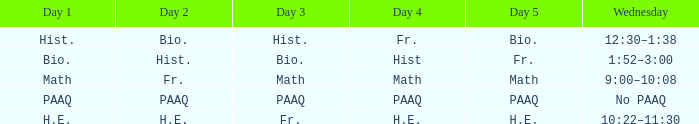What is the day 1 when day 5 is math? Math. 